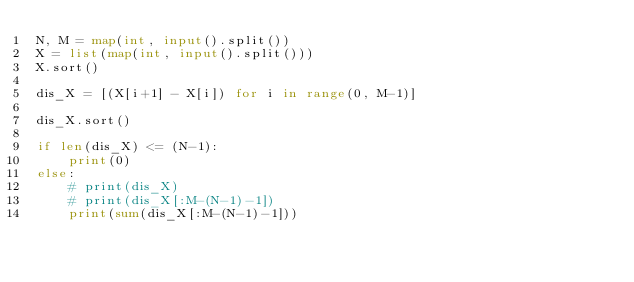Convert code to text. <code><loc_0><loc_0><loc_500><loc_500><_Python_>N, M = map(int, input().split())
X = list(map(int, input().split()))
X.sort()

dis_X = [(X[i+1] - X[i]) for i in range(0, M-1)]

dis_X.sort()

if len(dis_X) <= (N-1):
    print(0)
else:
    # print(dis_X)
    # print(dis_X[:M-(N-1)-1])
    print(sum(dis_X[:M-(N-1)-1]))</code> 